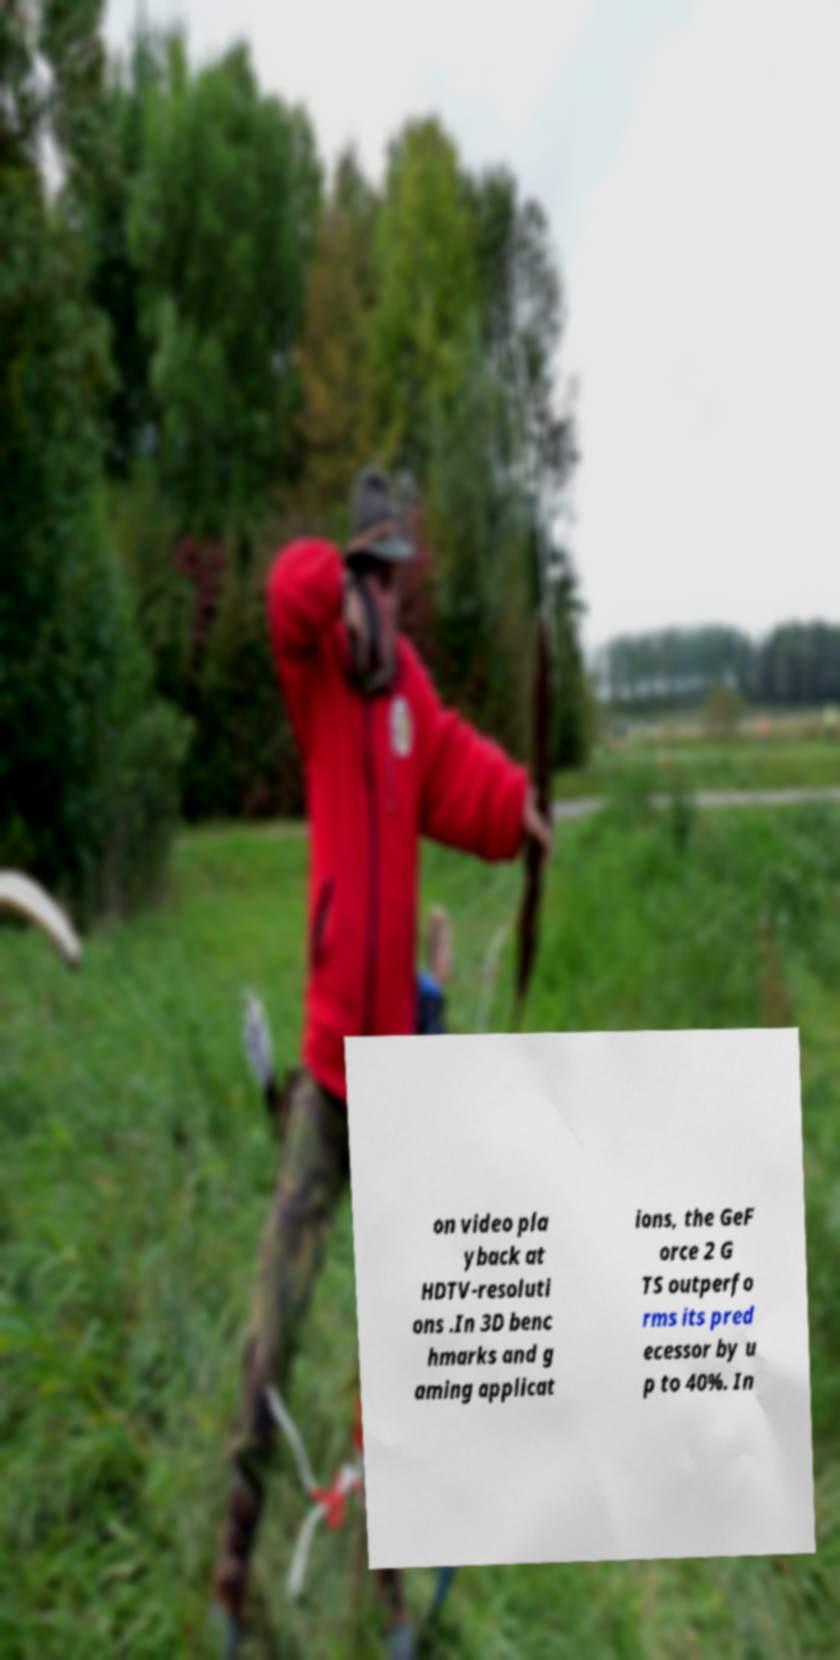Can you read and provide the text displayed in the image?This photo seems to have some interesting text. Can you extract and type it out for me? on video pla yback at HDTV-resoluti ons .In 3D benc hmarks and g aming applicat ions, the GeF orce 2 G TS outperfo rms its pred ecessor by u p to 40%. In 